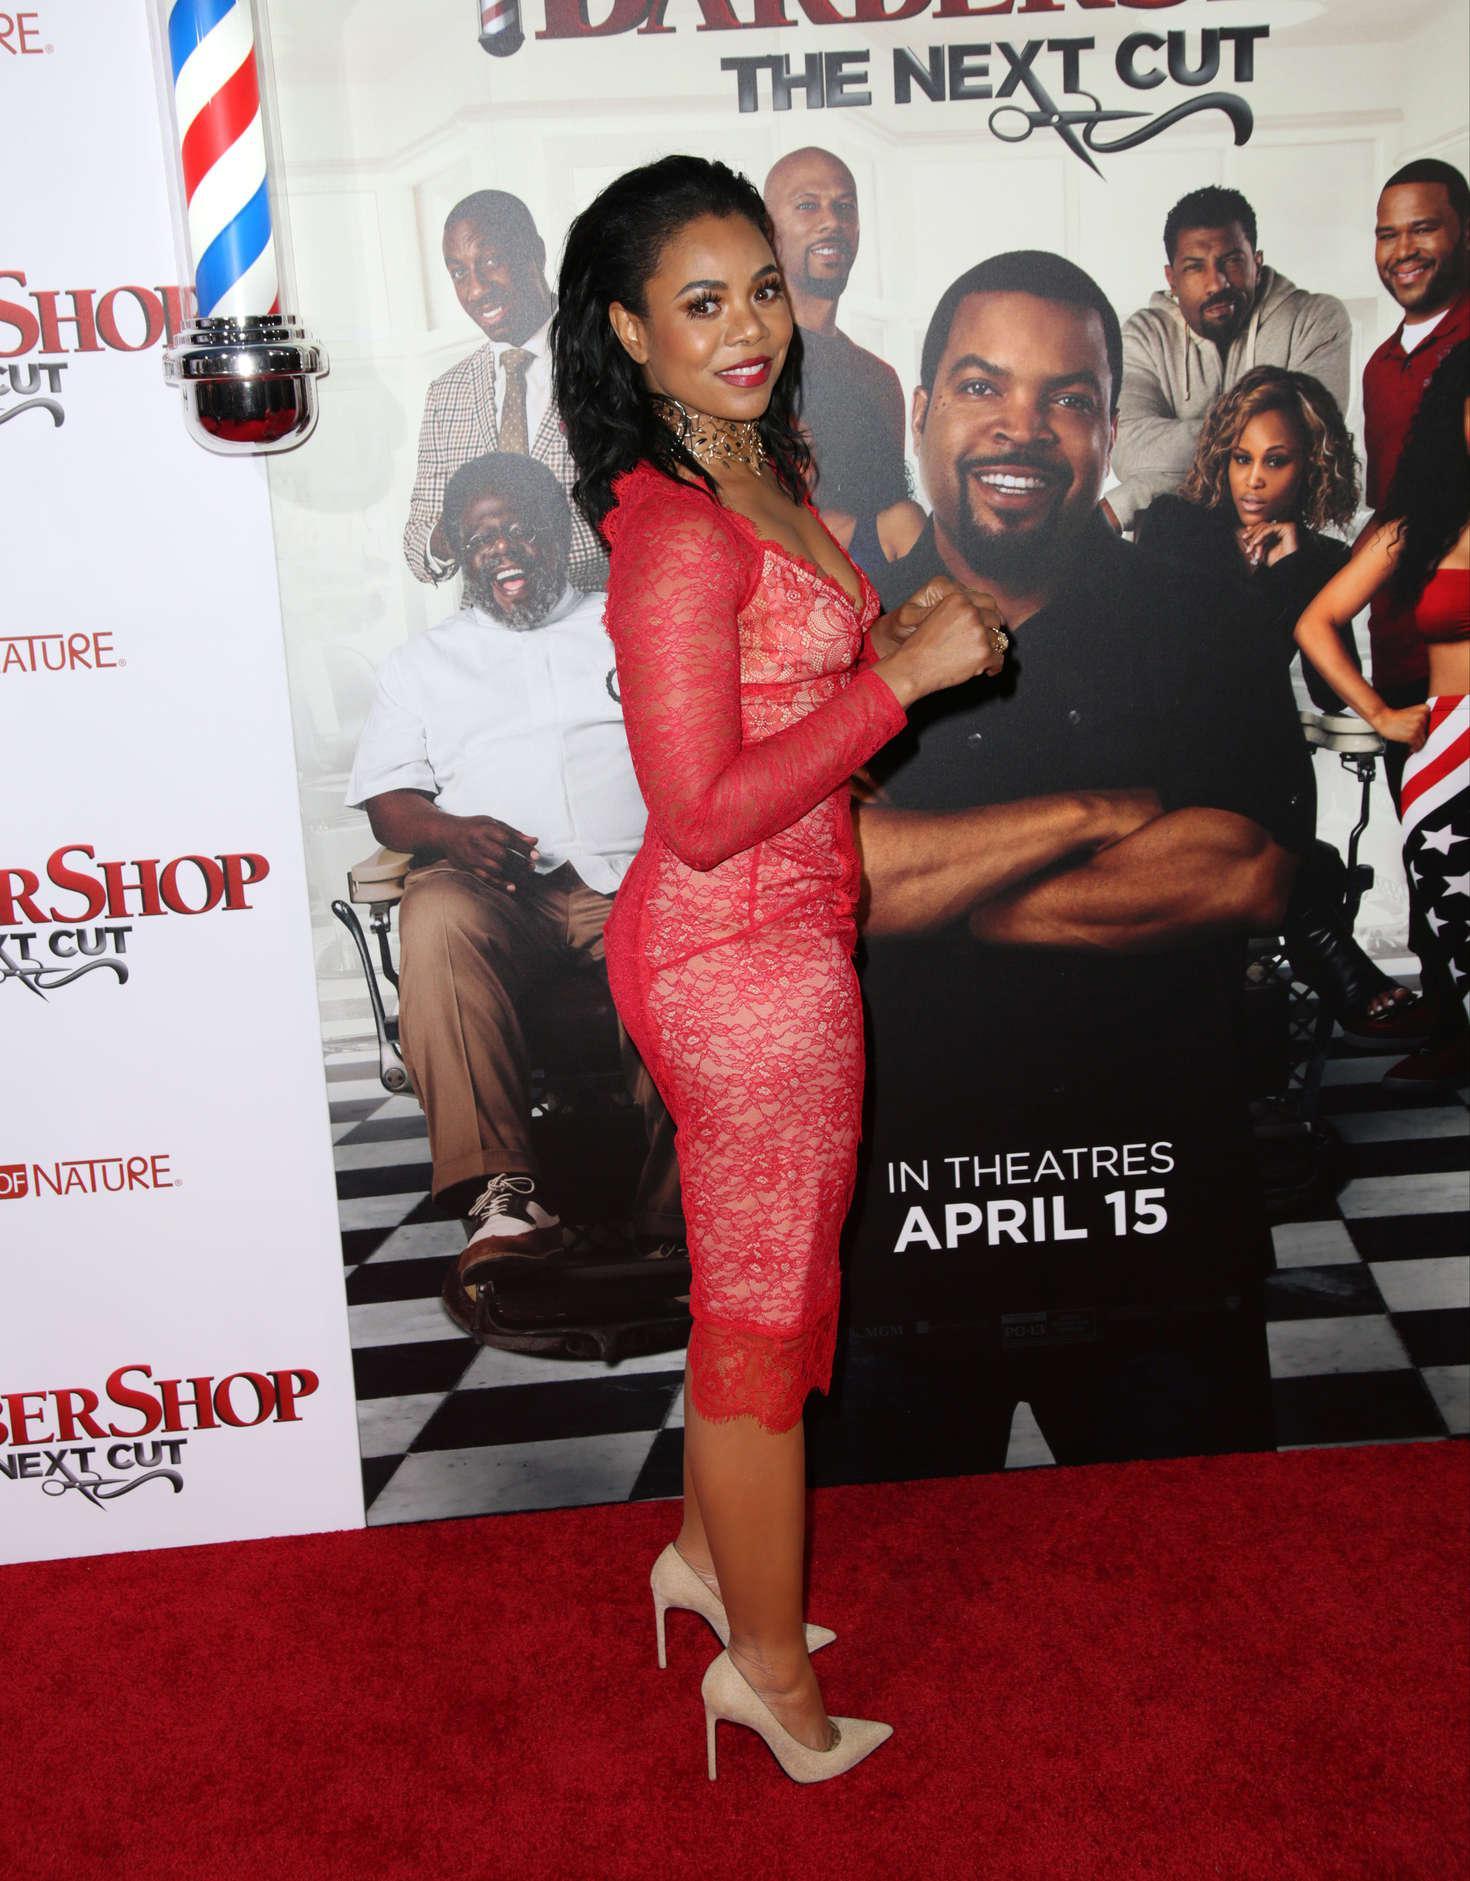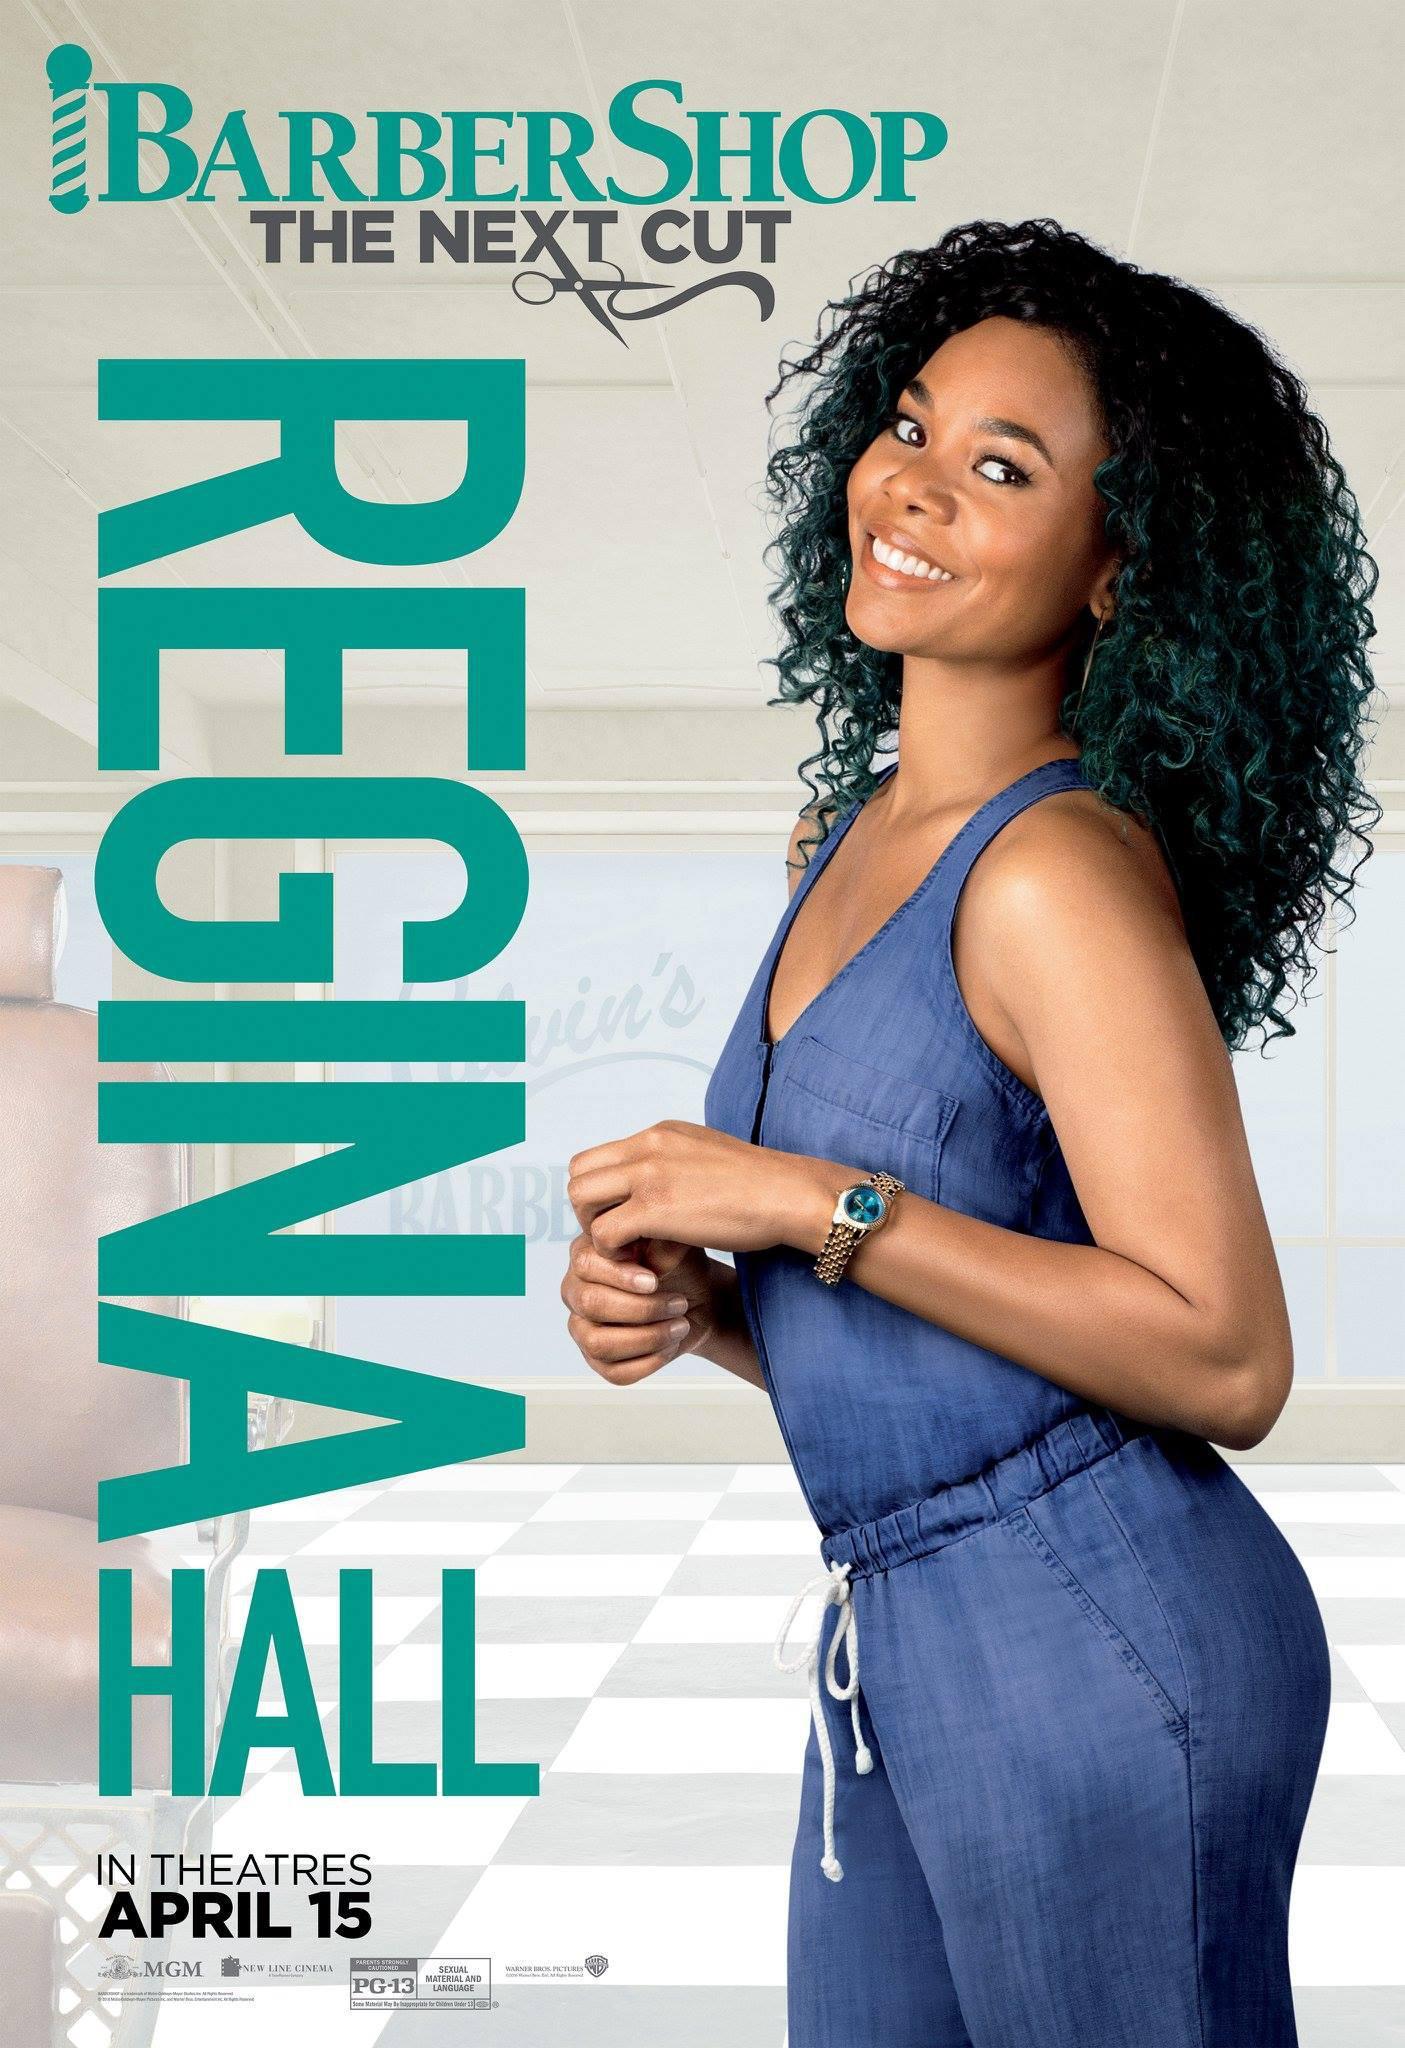The first image is the image on the left, the second image is the image on the right. For the images shown, is this caption "None of the women in the pictures have blue hair." true? Answer yes or no. Yes. 